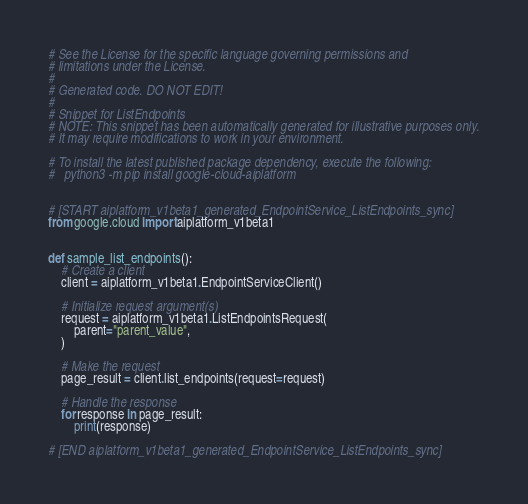<code> <loc_0><loc_0><loc_500><loc_500><_Python_># See the License for the specific language governing permissions and
# limitations under the License.
#
# Generated code. DO NOT EDIT!
#
# Snippet for ListEndpoints
# NOTE: This snippet has been automatically generated for illustrative purposes only.
# It may require modifications to work in your environment.

# To install the latest published package dependency, execute the following:
#   python3 -m pip install google-cloud-aiplatform


# [START aiplatform_v1beta1_generated_EndpointService_ListEndpoints_sync]
from google.cloud import aiplatform_v1beta1


def sample_list_endpoints():
    # Create a client
    client = aiplatform_v1beta1.EndpointServiceClient()

    # Initialize request argument(s)
    request = aiplatform_v1beta1.ListEndpointsRequest(
        parent="parent_value",
    )

    # Make the request
    page_result = client.list_endpoints(request=request)

    # Handle the response
    for response in page_result:
        print(response)

# [END aiplatform_v1beta1_generated_EndpointService_ListEndpoints_sync]
</code> 